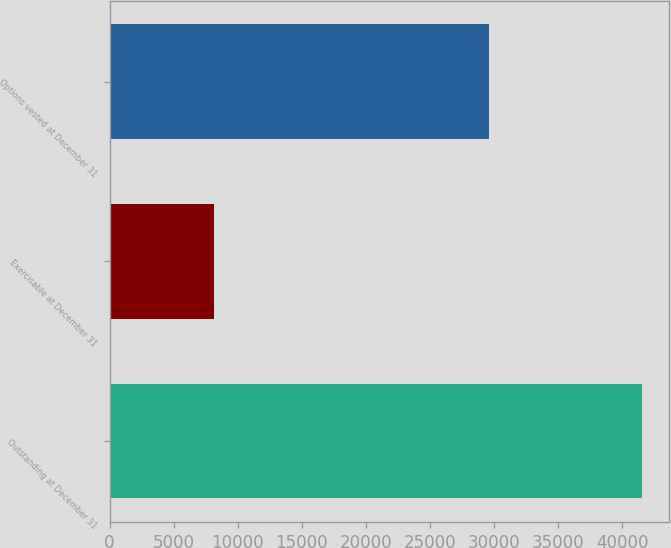Convert chart. <chart><loc_0><loc_0><loc_500><loc_500><bar_chart><fcel>Outstanding at December 31<fcel>Exercisable at December 31<fcel>Options vested at December 31<nl><fcel>41537<fcel>8172<fcel>29570<nl></chart> 